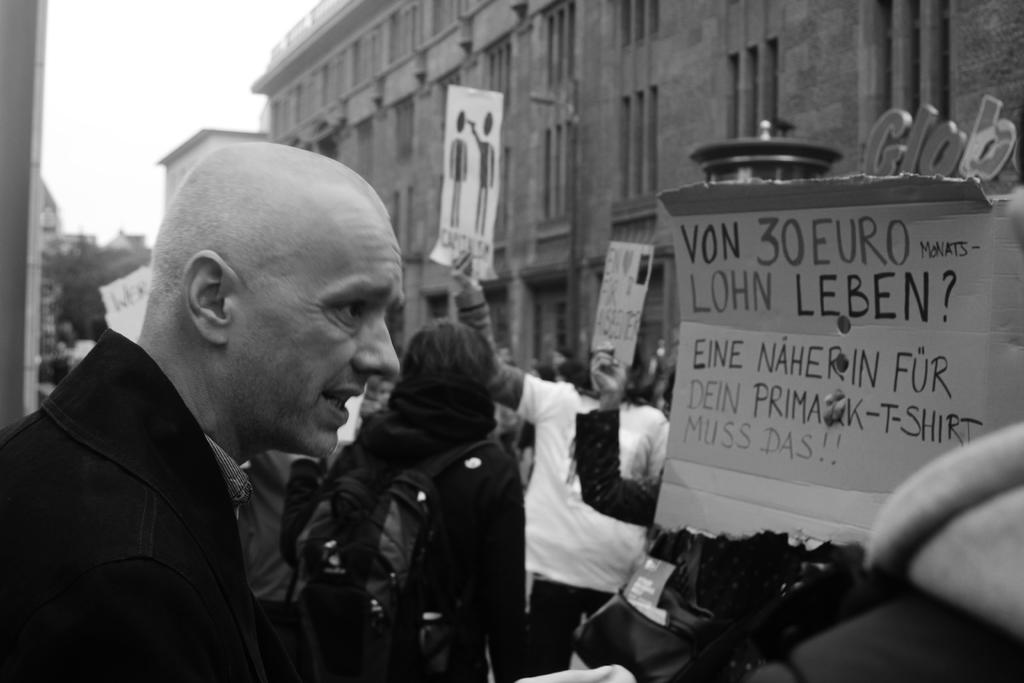What are the people in the image doing? The people in the image are standing in the center and holding boards in their hands. What can be seen in the background of the image? There are buildings and the sky visible in the background of the image. What type of spring can be seen in the image? There is no spring present in the image. What kind of space vehicle is visible in the image? There is no space vehicle present in the image. 